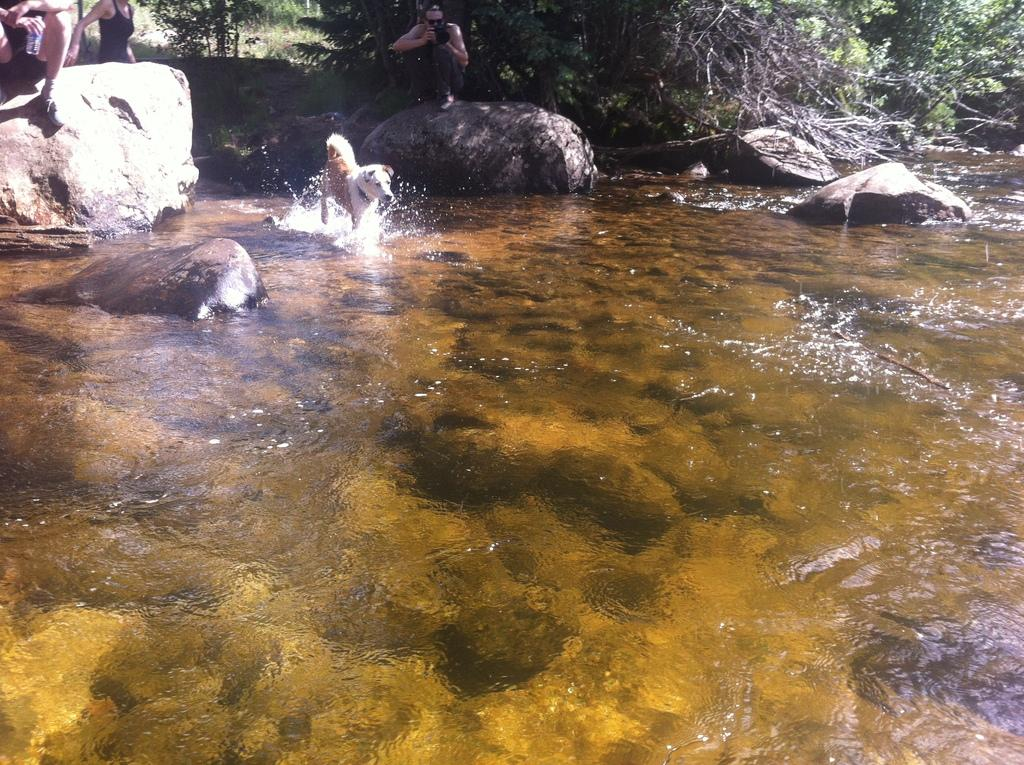What is the dog doing in the image? The dog is in the water. Where are the people located in the image? The people are seated on rocks. What can be seen in the background of the image? There are trees visible in the background. What type of news can be heard coming from the church in the image? There is no church present in the image, so it's not possible to determine what, if any, news might be heard. 